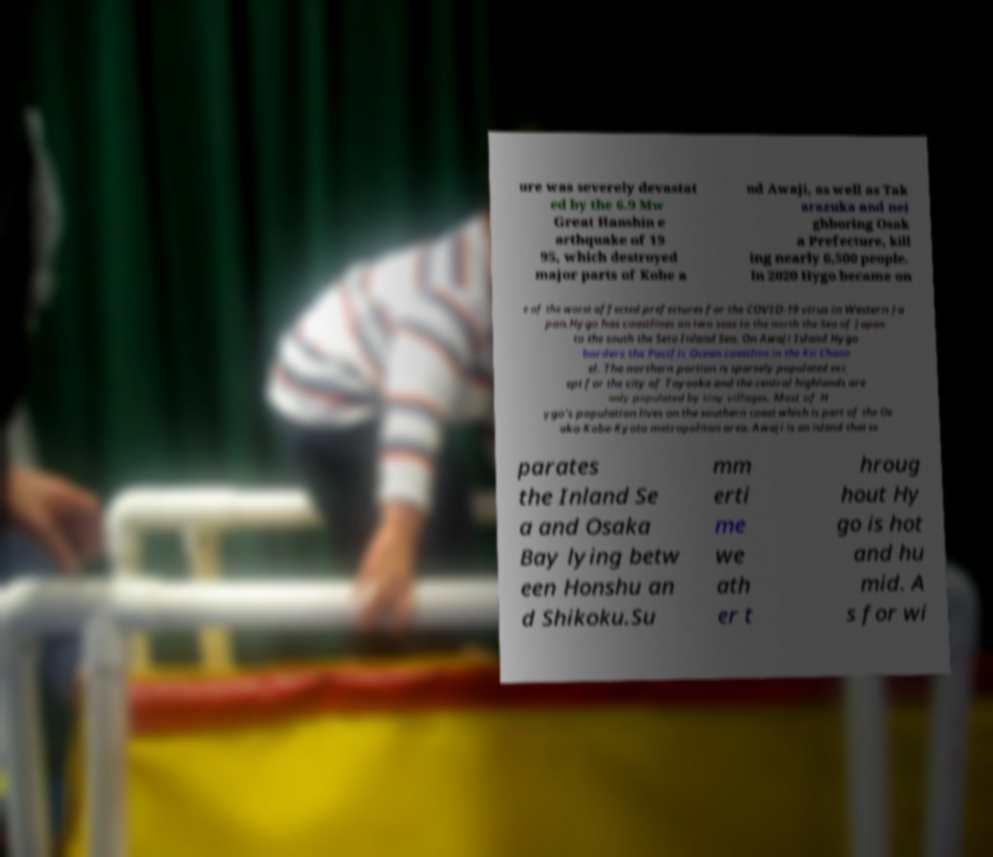There's text embedded in this image that I need extracted. Can you transcribe it verbatim? ure was severely devastat ed by the 6.9 Mw Great Hanshin e arthquake of 19 95, which destroyed major parts of Kobe a nd Awaji, as well as Tak arazuka and nei ghboring Osak a Prefecture, kill ing nearly 6,500 people. In 2020 Hygo became on e of the worst affected prefectures for the COVID-19 virus in Western Ja pan.Hygo has coastlines on two seas to the north the Sea of Japan to the south the Seto Inland Sea. On Awaji Island Hygo borders the Pacific Ocean coastline in the Kii Chann el. The northern portion is sparsely populated exc ept for the city of Toyooka and the central highlands are only populated by tiny villages. Most of H ygo's population lives on the southern coast which is part of the Os aka-Kobe-Kyoto metropolitan area. Awaji is an island that se parates the Inland Se a and Osaka Bay lying betw een Honshu an d Shikoku.Su mm erti me we ath er t hroug hout Hy go is hot and hu mid. A s for wi 